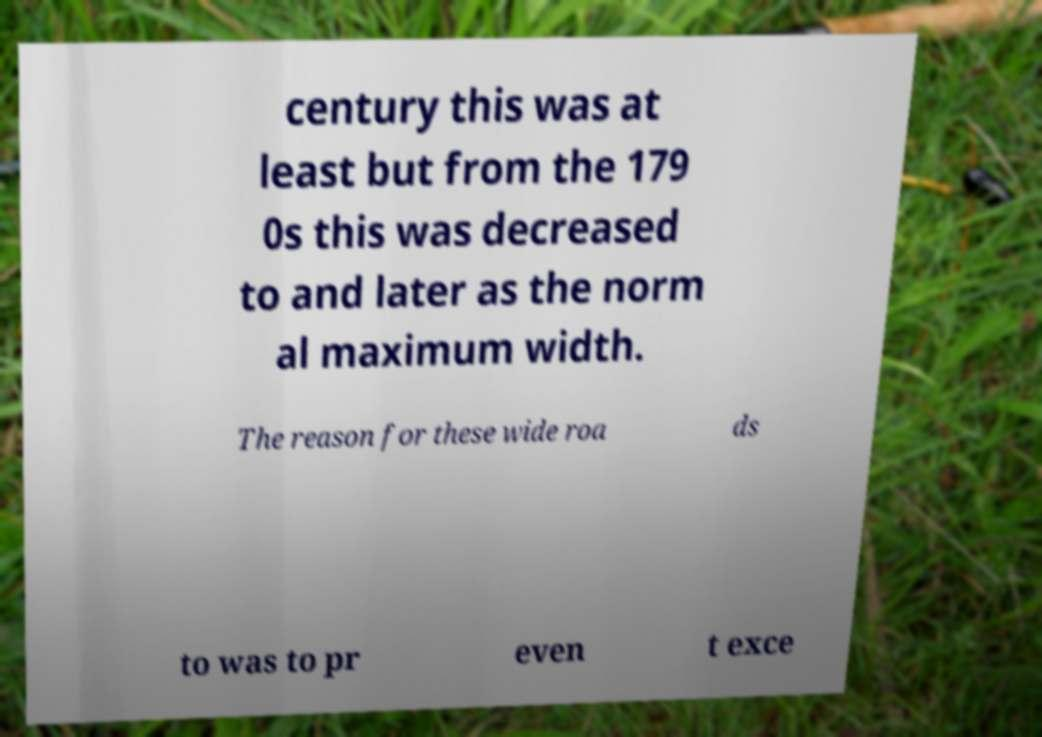There's text embedded in this image that I need extracted. Can you transcribe it verbatim? century this was at least but from the 179 0s this was decreased to and later as the norm al maximum width. The reason for these wide roa ds to was to pr even t exce 